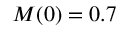<formula> <loc_0><loc_0><loc_500><loc_500>M ( 0 ) = 0 . 7</formula> 